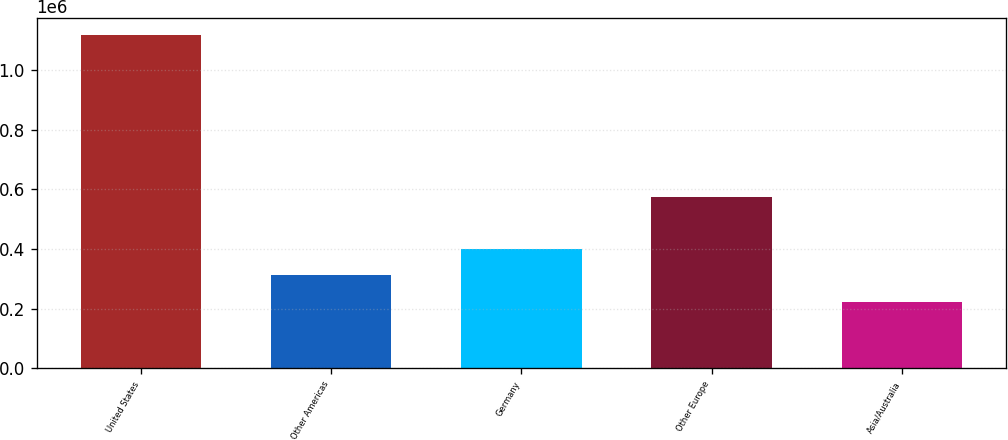Convert chart to OTSL. <chart><loc_0><loc_0><loc_500><loc_500><bar_chart><fcel>United States<fcel>Other Americas<fcel>Germany<fcel>Other Europe<fcel>Asia/Australia<nl><fcel>1.11998e+06<fcel>311503<fcel>401333<fcel>574451<fcel>221672<nl></chart> 